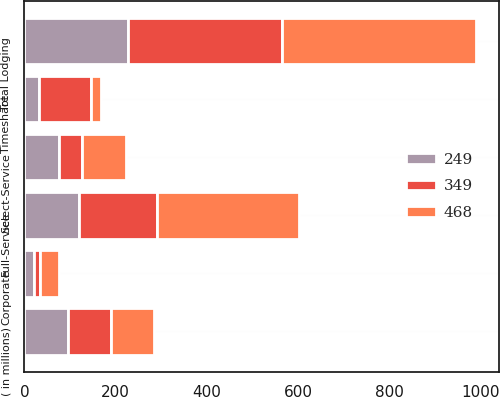Convert chart to OTSL. <chart><loc_0><loc_0><loc_500><loc_500><stacked_bar_chart><ecel><fcel>( in millions)<fcel>Full-Service<fcel>Select-Service<fcel>Timeshare<fcel>Total Lodging<fcel>Corporate<nl><fcel>349<fcel>95<fcel>171<fcel>50<fcel>115<fcel>336<fcel>13<nl><fcel>249<fcel>95<fcel>120<fcel>77<fcel>31<fcel>228<fcel>21<nl><fcel>468<fcel>95<fcel>310<fcel>95<fcel>22<fcel>427<fcel>41<nl></chart> 